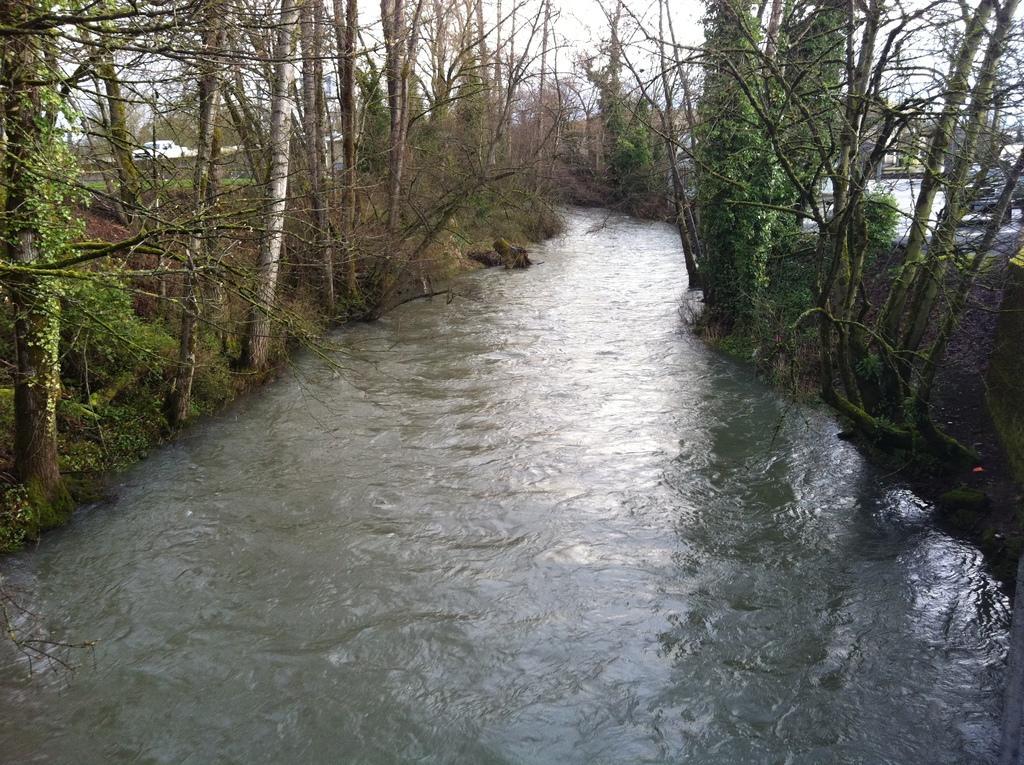How would you summarize this image in a sentence or two? In this picture there is river in the foreground. On the left side of the image there is a vehicle and there are trees. On the right side of the image where it looks like a vehicle and there are trees. At the top there is sky. At the bottom there is water. 